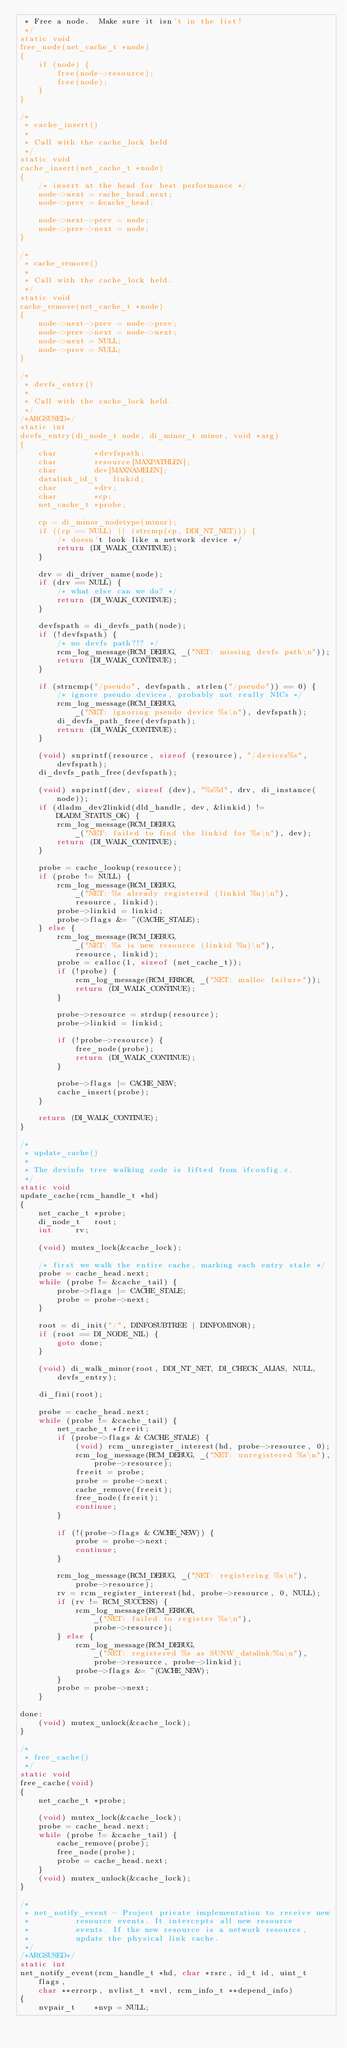<code> <loc_0><loc_0><loc_500><loc_500><_C_> * Free a node.  Make sure it isn't in the list!
 */
static void
free_node(net_cache_t *node)
{
	if (node) {
		free(node->resource);
		free(node);
	}
}

/*
 * cache_insert()
 *
 * Call with the cache_lock held.
 */
static void
cache_insert(net_cache_t *node)
{
	/* insert at the head for best performance */
	node->next = cache_head.next;
	node->prev = &cache_head;

	node->next->prev = node;
	node->prev->next = node;
}

/*
 * cache_remove()
 *
 * Call with the cache_lock held.
 */
static void
cache_remove(net_cache_t *node)
{
	node->next->prev = node->prev;
	node->prev->next = node->next;
	node->next = NULL;
	node->prev = NULL;
}

/*
 * devfs_entry()
 *
 * Call with the cache_lock held.
 */
/*ARGSUSED*/
static int
devfs_entry(di_node_t node, di_minor_t minor, void *arg)
{
	char		*devfspath;
	char		resource[MAXPATHLEN];
	char		dev[MAXNAMELEN];
	datalink_id_t	linkid;
	char		*drv;
	char		*cp;
	net_cache_t	*probe;

	cp = di_minor_nodetype(minor);
	if ((cp == NULL) || (strcmp(cp, DDI_NT_NET))) {
		/* doesn't look like a network device */
		return (DI_WALK_CONTINUE);
	}

	drv = di_driver_name(node);
	if (drv == NULL) {
		/* what else can we do? */
		return (DI_WALK_CONTINUE);
	}

	devfspath = di_devfs_path(node);
	if (!devfspath) {
		/* no devfs path?!? */
		rcm_log_message(RCM_DEBUG, _("NET: missing devfs path\n"));
		return (DI_WALK_CONTINUE);
	}

	if (strncmp("/pseudo", devfspath, strlen("/pseudo")) == 0) {
		/* ignore pseudo devices, probably not really NICs */
		rcm_log_message(RCM_DEBUG,
		    _("NET: ignoring pseudo device %s\n"), devfspath);
		di_devfs_path_free(devfspath);
		return (DI_WALK_CONTINUE);
	}

	(void) snprintf(resource, sizeof (resource), "/devices%s", devfspath);
	di_devfs_path_free(devfspath);

	(void) snprintf(dev, sizeof (dev), "%s%d", drv, di_instance(node));
	if (dladm_dev2linkid(dld_handle, dev, &linkid) != DLADM_STATUS_OK) {
		rcm_log_message(RCM_DEBUG,
		    _("NET: failed to find the linkid for %s\n"), dev);
		return (DI_WALK_CONTINUE);
	}

	probe = cache_lookup(resource);
	if (probe != NULL) {
		rcm_log_message(RCM_DEBUG,
		    _("NET: %s already registered (linkid %u)\n"),
		    resource, linkid);
		probe->linkid = linkid;
		probe->flags &= ~(CACHE_STALE);
	} else {
		rcm_log_message(RCM_DEBUG,
		    _("NET: %s is new resource (linkid %u)\n"),
		    resource, linkid);
		probe = calloc(1, sizeof (net_cache_t));
		if (!probe) {
			rcm_log_message(RCM_ERROR, _("NET: malloc failure"));
			return (DI_WALK_CONTINUE);
		}

		probe->resource = strdup(resource);
		probe->linkid = linkid;

		if (!probe->resource) {
			free_node(probe);
			return (DI_WALK_CONTINUE);
		}

		probe->flags |= CACHE_NEW;
		cache_insert(probe);
	}

	return (DI_WALK_CONTINUE);
}

/*
 * update_cache()
 *
 * The devinfo tree walking code is lifted from ifconfig.c.
 */
static void
update_cache(rcm_handle_t *hd)
{
	net_cache_t	*probe;
	di_node_t	root;
	int		rv;

	(void) mutex_lock(&cache_lock);

	/* first we walk the entire cache, marking each entry stale */
	probe = cache_head.next;
	while (probe != &cache_tail) {
		probe->flags |= CACHE_STALE;
		probe = probe->next;
	}

	root = di_init("/", DINFOSUBTREE | DINFOMINOR);
	if (root == DI_NODE_NIL) {
		goto done;
	}

	(void) di_walk_minor(root, DDI_NT_NET, DI_CHECK_ALIAS, NULL,
	    devfs_entry);

	di_fini(root);

	probe = cache_head.next;
	while (probe != &cache_tail) {
		net_cache_t *freeit;
		if (probe->flags & CACHE_STALE) {
			(void) rcm_unregister_interest(hd, probe->resource, 0);
			rcm_log_message(RCM_DEBUG, _("NET: unregistered %s\n"),
			    probe->resource);
			freeit = probe;
			probe = probe->next;
			cache_remove(freeit);
			free_node(freeit);
			continue;
		}

		if (!(probe->flags & CACHE_NEW)) {
			probe = probe->next;
			continue;
		}

		rcm_log_message(RCM_DEBUG, _("NET: registering %s\n"),
		    probe->resource);
		rv = rcm_register_interest(hd, probe->resource, 0, NULL);
		if (rv != RCM_SUCCESS) {
			rcm_log_message(RCM_ERROR,
			    _("NET: failed to register %s\n"),
			    probe->resource);
		} else {
			rcm_log_message(RCM_DEBUG,
			    _("NET: registered %s as SUNW_datalink/%u\n"),
			    probe->resource, probe->linkid);
			probe->flags &= ~(CACHE_NEW);
		}
		probe = probe->next;
	}

done:
	(void) mutex_unlock(&cache_lock);
}

/*
 * free_cache()
 */
static void
free_cache(void)
{
	net_cache_t *probe;

	(void) mutex_lock(&cache_lock);
	probe = cache_head.next;
	while (probe != &cache_tail) {
		cache_remove(probe);
		free_node(probe);
		probe = cache_head.next;
	}
	(void) mutex_unlock(&cache_lock);
}

/*
 * net_notify_event - Project private implementation to receive new
 *			resource events. It intercepts all new resource
 *			events. If the new resource is a network resource,
 *			update the physical link cache.
 */
/*ARGSUSED*/
static int
net_notify_event(rcm_handle_t *hd, char *rsrc, id_t id, uint_t flags,
    char **errorp, nvlist_t *nvl, rcm_info_t **depend_info)
{
	nvpair_t	*nvp = NULL;</code> 